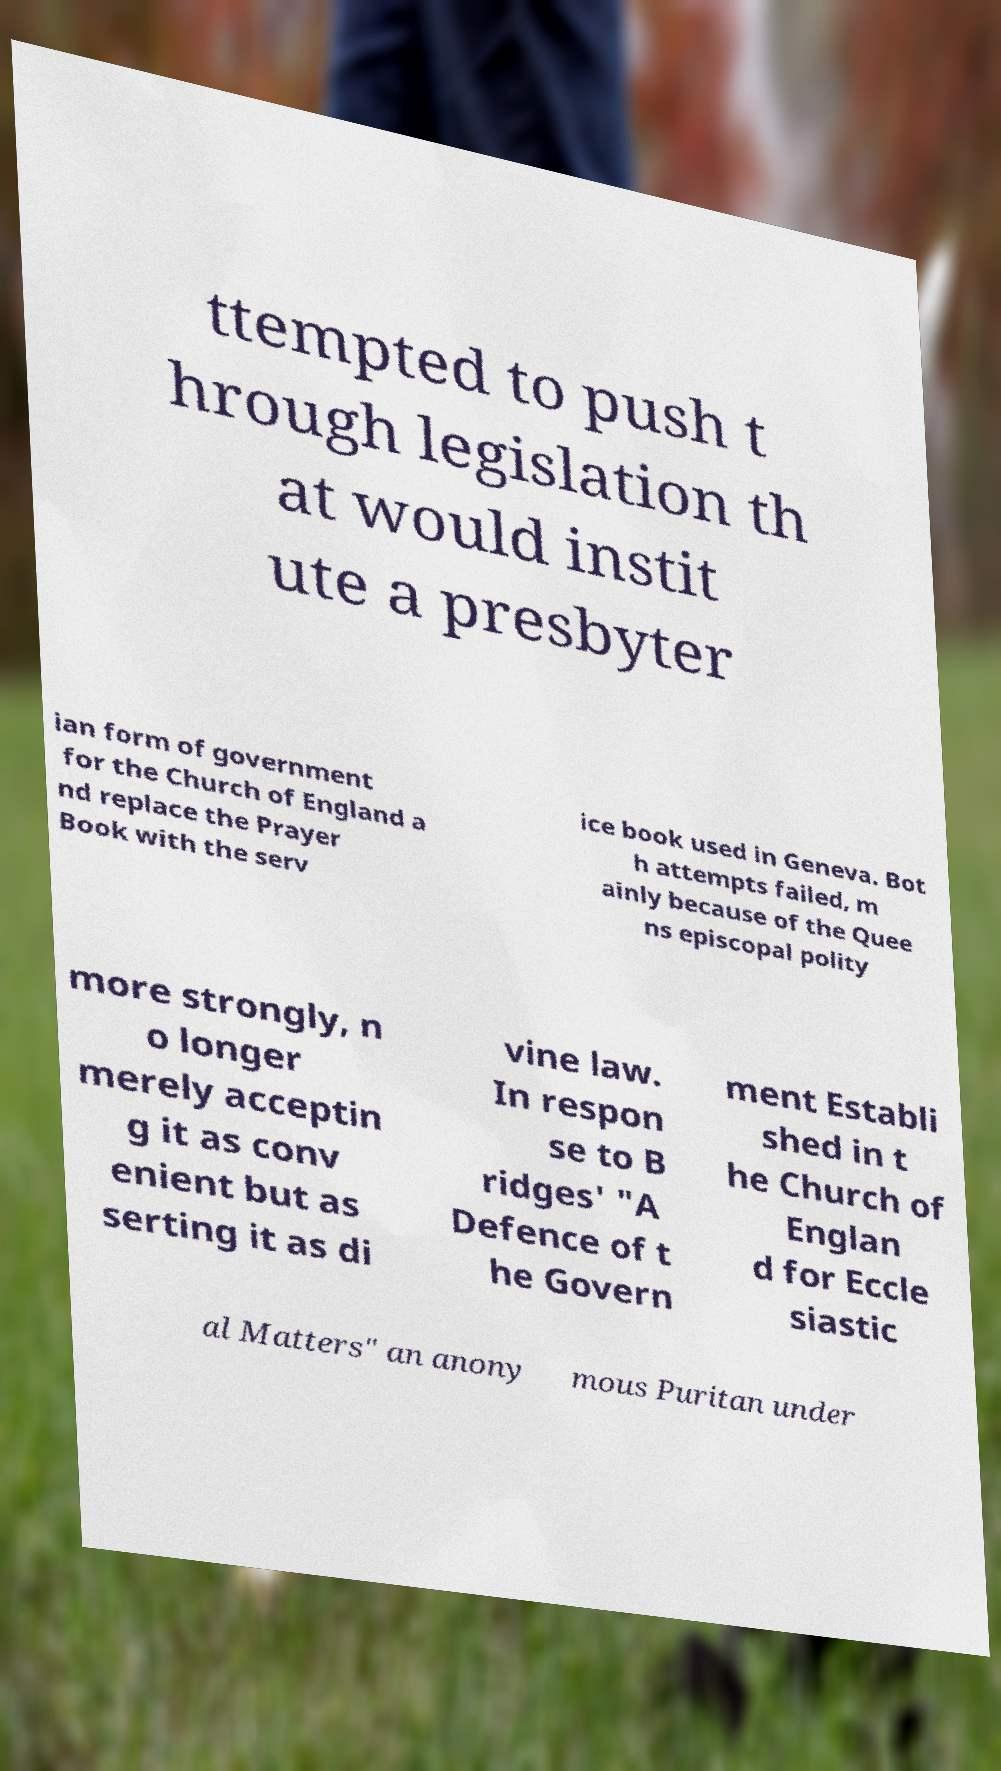Please read and relay the text visible in this image. What does it say? ttempted to push t hrough legislation th at would instit ute a presbyter ian form of government for the Church of England a nd replace the Prayer Book with the serv ice book used in Geneva. Bot h attempts failed, m ainly because of the Quee ns episcopal polity more strongly, n o longer merely acceptin g it as conv enient but as serting it as di vine law. In respon se to B ridges' "A Defence of t he Govern ment Establi shed in t he Church of Englan d for Eccle siastic al Matters" an anony mous Puritan under 